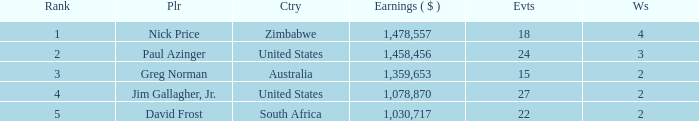Help me parse the entirety of this table. {'header': ['Rank', 'Plr', 'Ctry', 'Earnings ( $ )', 'Evts', 'Ws'], 'rows': [['1', 'Nick Price', 'Zimbabwe', '1,478,557', '18', '4'], ['2', 'Paul Azinger', 'United States', '1,458,456', '24', '3'], ['3', 'Greg Norman', 'Australia', '1,359,653', '15', '2'], ['4', 'Jim Gallagher, Jr.', 'United States', '1,078,870', '27', '2'], ['5', 'David Frost', 'South Africa', '1,030,717', '22', '2']]} How many events are in South Africa? 22.0. 